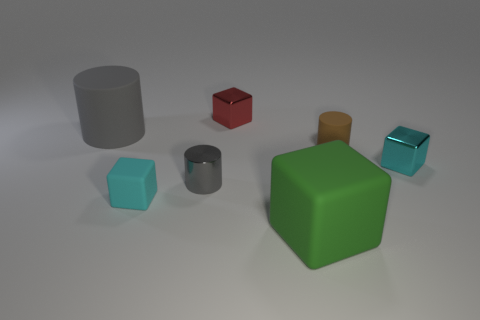Subtract all brown cylinders. How many cylinders are left? 2 Subtract all gray cylinders. How many cylinders are left? 1 Add 1 brown things. How many objects exist? 8 Subtract all purple cubes. How many gray cylinders are left? 2 Subtract all cylinders. How many objects are left? 4 Subtract 2 blocks. How many blocks are left? 2 Subtract all gray shiny cylinders. Subtract all gray metallic cylinders. How many objects are left? 5 Add 6 large gray rubber cylinders. How many large gray rubber cylinders are left? 7 Add 5 small objects. How many small objects exist? 10 Subtract 1 brown cylinders. How many objects are left? 6 